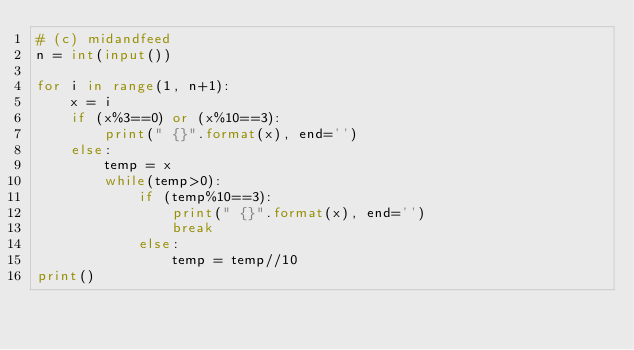Convert code to text. <code><loc_0><loc_0><loc_500><loc_500><_Python_># (c) midandfeed
n = int(input())
	
for i in range(1, n+1):
	x = i
	if (x%3==0) or (x%10==3):
		print(" {}".format(x), end='')
	else:
		temp = x
		while(temp>0):
			if (temp%10==3):
				print(" {}".format(x), end='')
				break
			else:
				temp = temp//10
print()
	</code> 